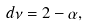Convert formula to latex. <formula><loc_0><loc_0><loc_500><loc_500>d \nu = 2 - \alpha ,</formula> 